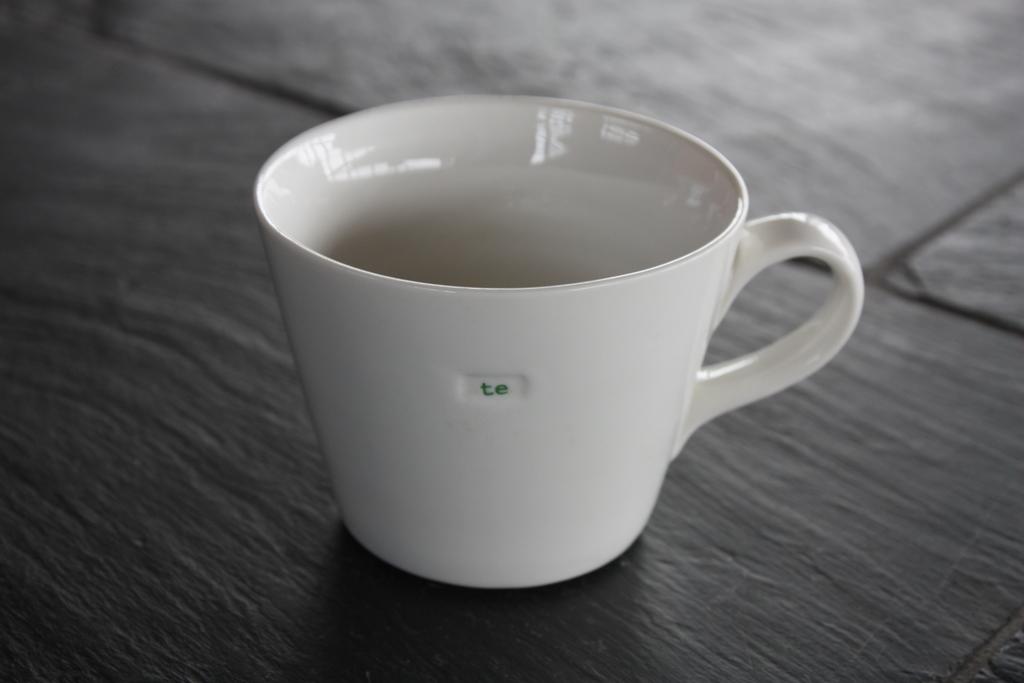What two letters are on the mug?
Ensure brevity in your answer.  Te. What is the first letter on the mug?
Make the answer very short. T. 